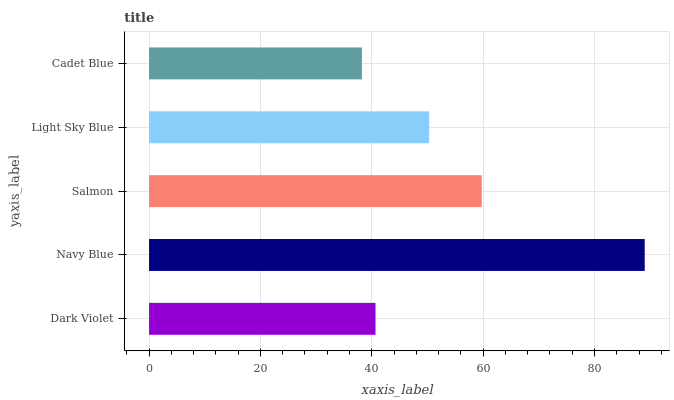Is Cadet Blue the minimum?
Answer yes or no. Yes. Is Navy Blue the maximum?
Answer yes or no. Yes. Is Salmon the minimum?
Answer yes or no. No. Is Salmon the maximum?
Answer yes or no. No. Is Navy Blue greater than Salmon?
Answer yes or no. Yes. Is Salmon less than Navy Blue?
Answer yes or no. Yes. Is Salmon greater than Navy Blue?
Answer yes or no. No. Is Navy Blue less than Salmon?
Answer yes or no. No. Is Light Sky Blue the high median?
Answer yes or no. Yes. Is Light Sky Blue the low median?
Answer yes or no. Yes. Is Salmon the high median?
Answer yes or no. No. Is Cadet Blue the low median?
Answer yes or no. No. 